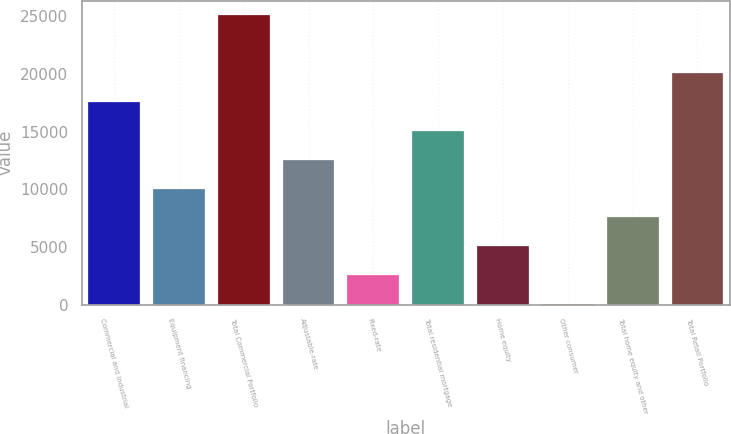Convert chart. <chart><loc_0><loc_0><loc_500><loc_500><bar_chart><fcel>Commercial and industrial<fcel>Equipment financing<fcel>Total Commercial Portfolio<fcel>Adjustable-rate<fcel>Fixed-rate<fcel>Total residential mortgage<fcel>Home equity<fcel>Other consumer<fcel>Total home equity and other<fcel>Total Retail Portfolio<nl><fcel>17568.5<fcel>10059.3<fcel>25077.7<fcel>12562.4<fcel>2550.07<fcel>15065.4<fcel>5053.14<fcel>47<fcel>7556.21<fcel>20071.6<nl></chart> 